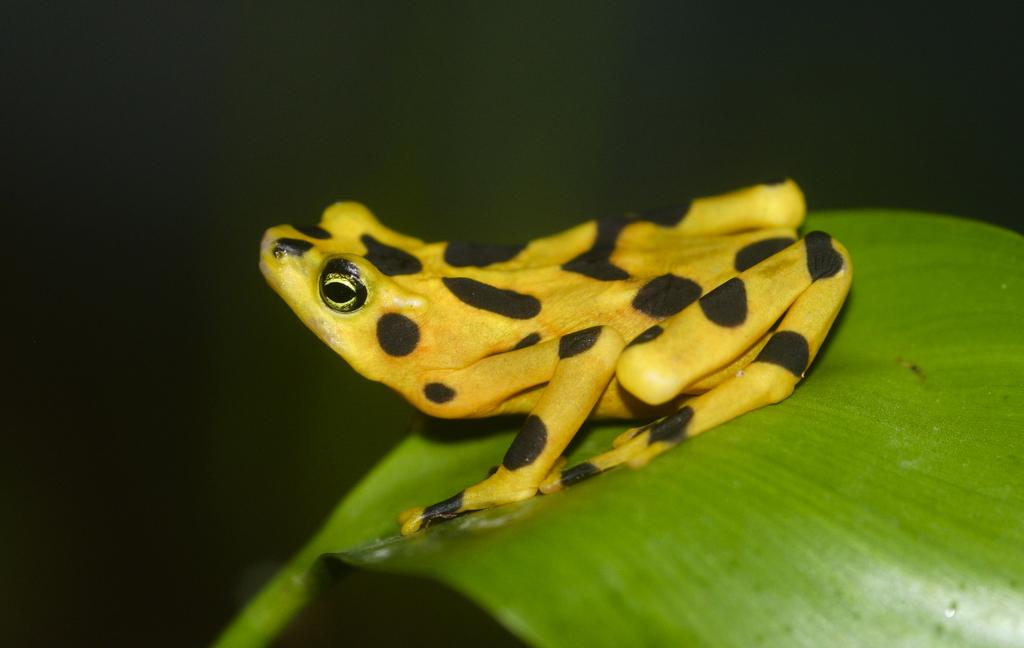What animal is present in the image? There is a frog in the image. Where is the frog located? The frog is on a leaf. Can you describe the background of the image? The background of the image is blurred. What type of collar does the frog have in the image? There is no collar present on the frog in the image. 